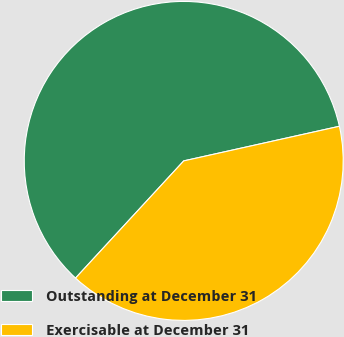<chart> <loc_0><loc_0><loc_500><loc_500><pie_chart><fcel>Outstanding at December 31<fcel>Exercisable at December 31<nl><fcel>59.65%<fcel>40.35%<nl></chart> 